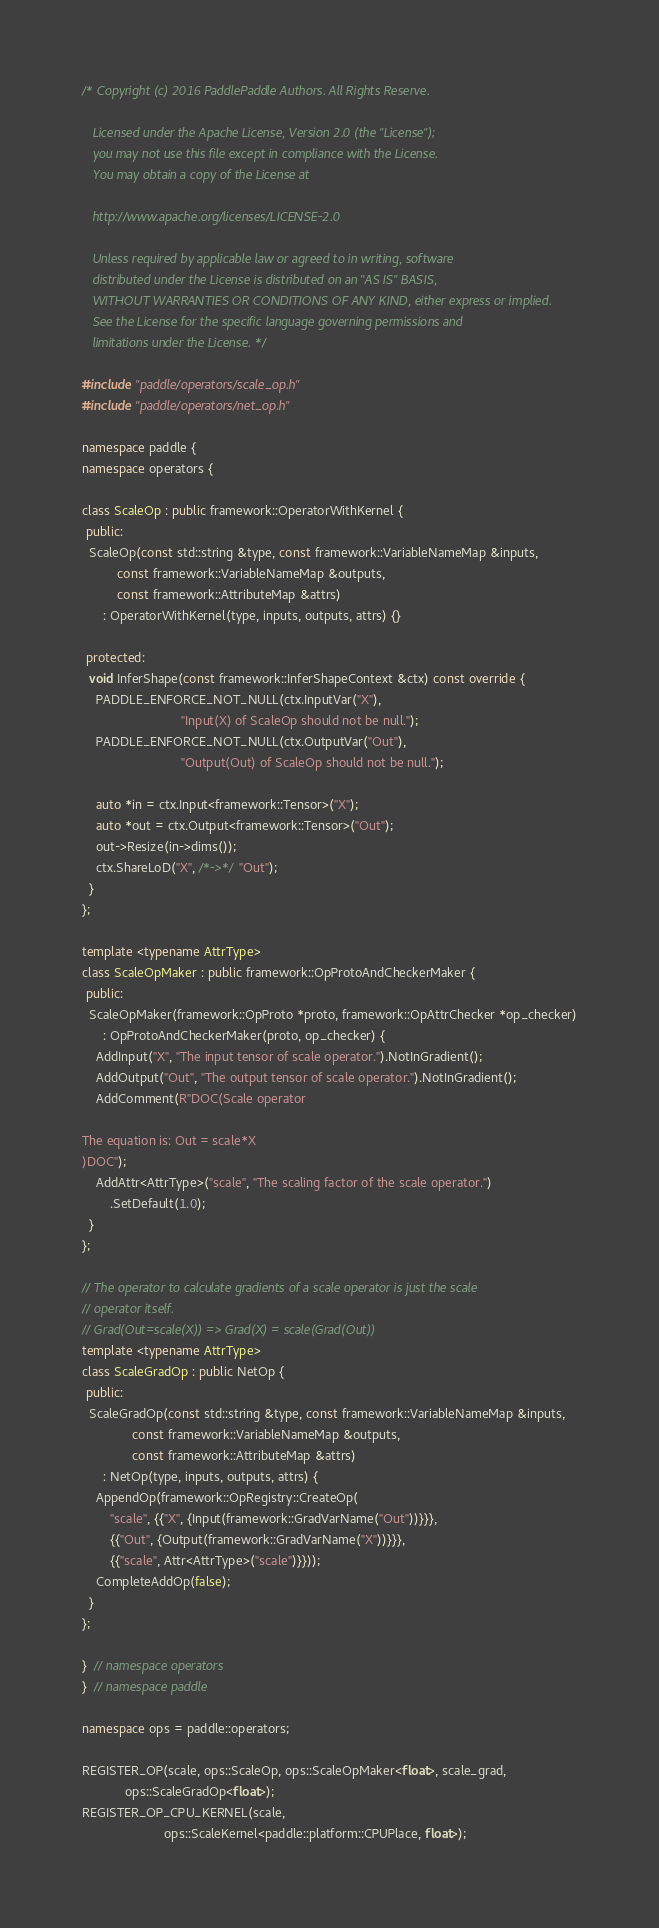<code> <loc_0><loc_0><loc_500><loc_500><_C++_>/* Copyright (c) 2016 PaddlePaddle Authors. All Rights Reserve.

   Licensed under the Apache License, Version 2.0 (the "License");
   you may not use this file except in compliance with the License.
   You may obtain a copy of the License at

   http://www.apache.org/licenses/LICENSE-2.0

   Unless required by applicable law or agreed to in writing, software
   distributed under the License is distributed on an "AS IS" BASIS,
   WITHOUT WARRANTIES OR CONDITIONS OF ANY KIND, either express or implied.
   See the License for the specific language governing permissions and
   limitations under the License. */

#include "paddle/operators/scale_op.h"
#include "paddle/operators/net_op.h"

namespace paddle {
namespace operators {

class ScaleOp : public framework::OperatorWithKernel {
 public:
  ScaleOp(const std::string &type, const framework::VariableNameMap &inputs,
          const framework::VariableNameMap &outputs,
          const framework::AttributeMap &attrs)
      : OperatorWithKernel(type, inputs, outputs, attrs) {}

 protected:
  void InferShape(const framework::InferShapeContext &ctx) const override {
    PADDLE_ENFORCE_NOT_NULL(ctx.InputVar("X"),
                            "Input(X) of ScaleOp should not be null.");
    PADDLE_ENFORCE_NOT_NULL(ctx.OutputVar("Out"),
                            "Output(Out) of ScaleOp should not be null.");

    auto *in = ctx.Input<framework::Tensor>("X");
    auto *out = ctx.Output<framework::Tensor>("Out");
    out->Resize(in->dims());
    ctx.ShareLoD("X", /*->*/ "Out");
  }
};

template <typename AttrType>
class ScaleOpMaker : public framework::OpProtoAndCheckerMaker {
 public:
  ScaleOpMaker(framework::OpProto *proto, framework::OpAttrChecker *op_checker)
      : OpProtoAndCheckerMaker(proto, op_checker) {
    AddInput("X", "The input tensor of scale operator.").NotInGradient();
    AddOutput("Out", "The output tensor of scale operator.").NotInGradient();
    AddComment(R"DOC(Scale operator

The equation is: Out = scale*X
)DOC");
    AddAttr<AttrType>("scale", "The scaling factor of the scale operator.")
        .SetDefault(1.0);
  }
};

// The operator to calculate gradients of a scale operator is just the scale
// operator itself.
// Grad(Out=scale(X)) => Grad(X) = scale(Grad(Out))
template <typename AttrType>
class ScaleGradOp : public NetOp {
 public:
  ScaleGradOp(const std::string &type, const framework::VariableNameMap &inputs,
              const framework::VariableNameMap &outputs,
              const framework::AttributeMap &attrs)
      : NetOp(type, inputs, outputs, attrs) {
    AppendOp(framework::OpRegistry::CreateOp(
        "scale", {{"X", {Input(framework::GradVarName("Out"))}}},
        {{"Out", {Output(framework::GradVarName("X"))}}},
        {{"scale", Attr<AttrType>("scale")}}));
    CompleteAddOp(false);
  }
};

}  // namespace operators
}  // namespace paddle

namespace ops = paddle::operators;

REGISTER_OP(scale, ops::ScaleOp, ops::ScaleOpMaker<float>, scale_grad,
            ops::ScaleGradOp<float>);
REGISTER_OP_CPU_KERNEL(scale,
                       ops::ScaleKernel<paddle::platform::CPUPlace, float>);
</code> 